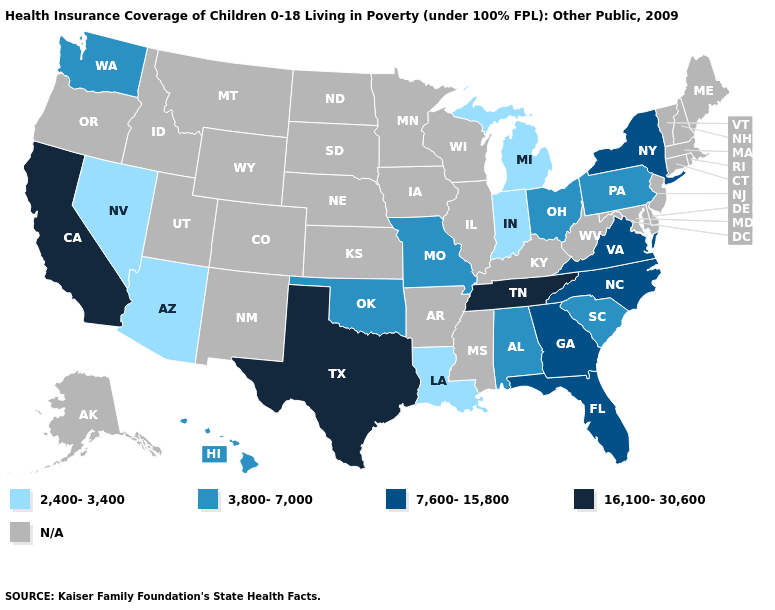What is the lowest value in states that border Mississippi?
Concise answer only. 2,400-3,400. Does the first symbol in the legend represent the smallest category?
Give a very brief answer. Yes. What is the value of Wyoming?
Quick response, please. N/A. What is the value of Montana?
Concise answer only. N/A. Which states hav the highest value in the West?
Be succinct. California. How many symbols are there in the legend?
Concise answer only. 5. Among the states that border Indiana , which have the lowest value?
Concise answer only. Michigan. What is the highest value in the West ?
Be succinct. 16,100-30,600. Among the states that border Vermont , which have the lowest value?
Be succinct. New York. What is the highest value in the USA?
Short answer required. 16,100-30,600. What is the value of California?
Write a very short answer. 16,100-30,600. What is the value of Missouri?
Answer briefly. 3,800-7,000. Does Arizona have the highest value in the West?
Answer briefly. No. What is the highest value in states that border Florida?
Quick response, please. 7,600-15,800. 